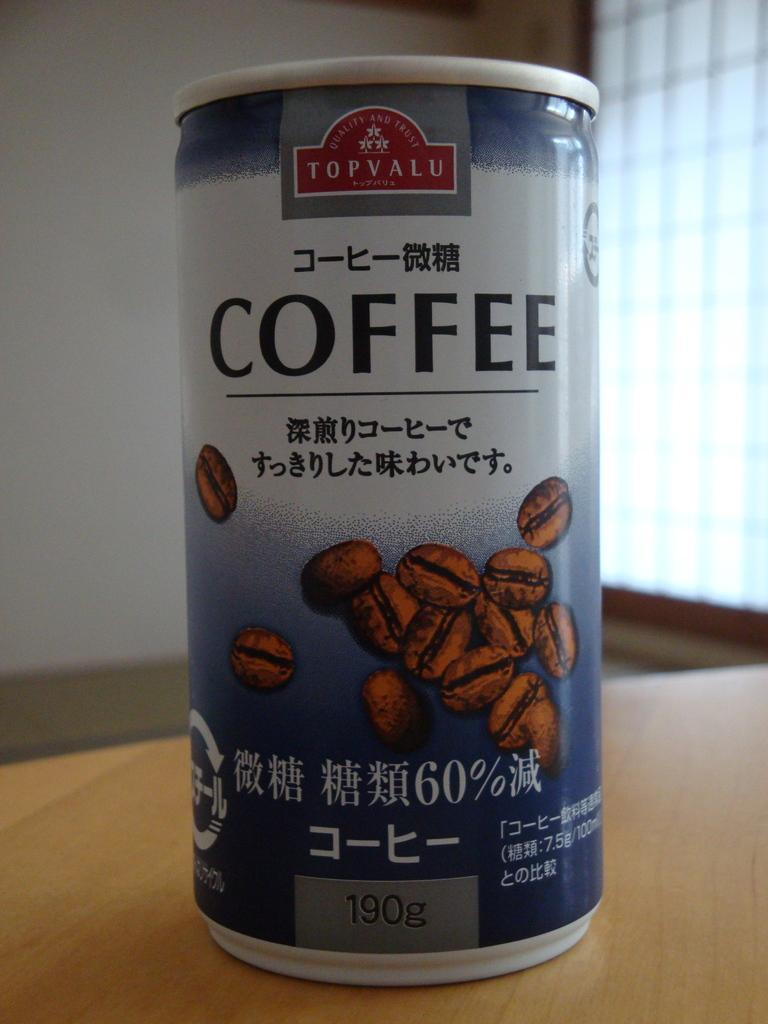<image>
Create a compact narrative representing the image presented. A can of Topvalu coffee with images of coffee beans on it. 